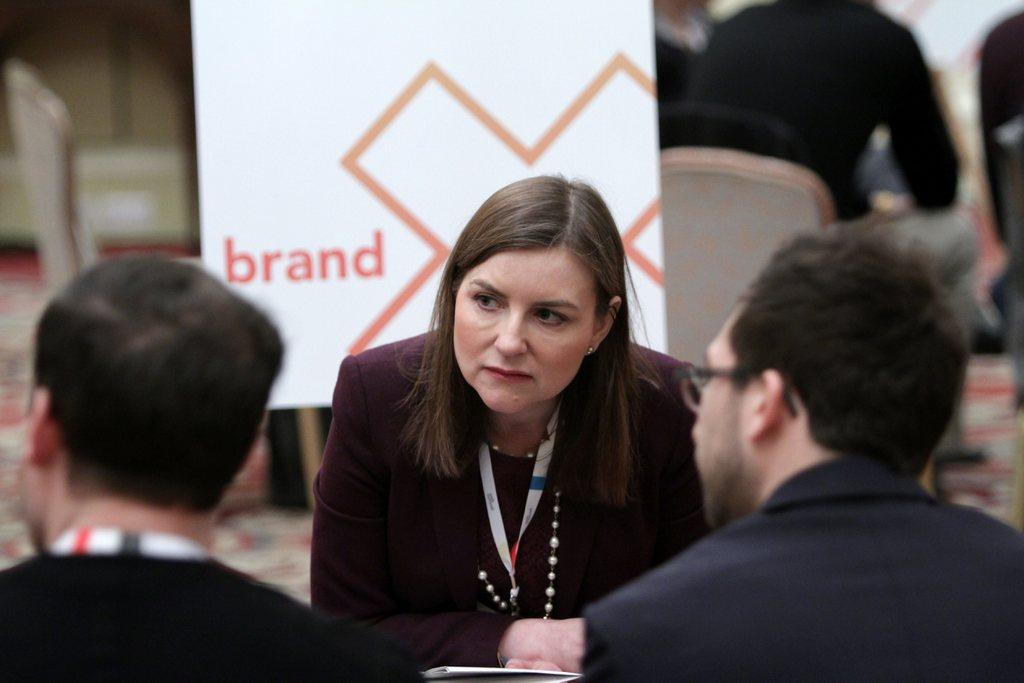Who is the main subject in the center of the image? There is a lady in the center of the image. How many people are at the bottom of the image? There are two people at the bottom of the image. What can be seen in the background of the image? There are people sitting in chairs and a board visible in the background of the image. Can you see a river flowing behind the lady in the image? No, there is no river visible in the image. 